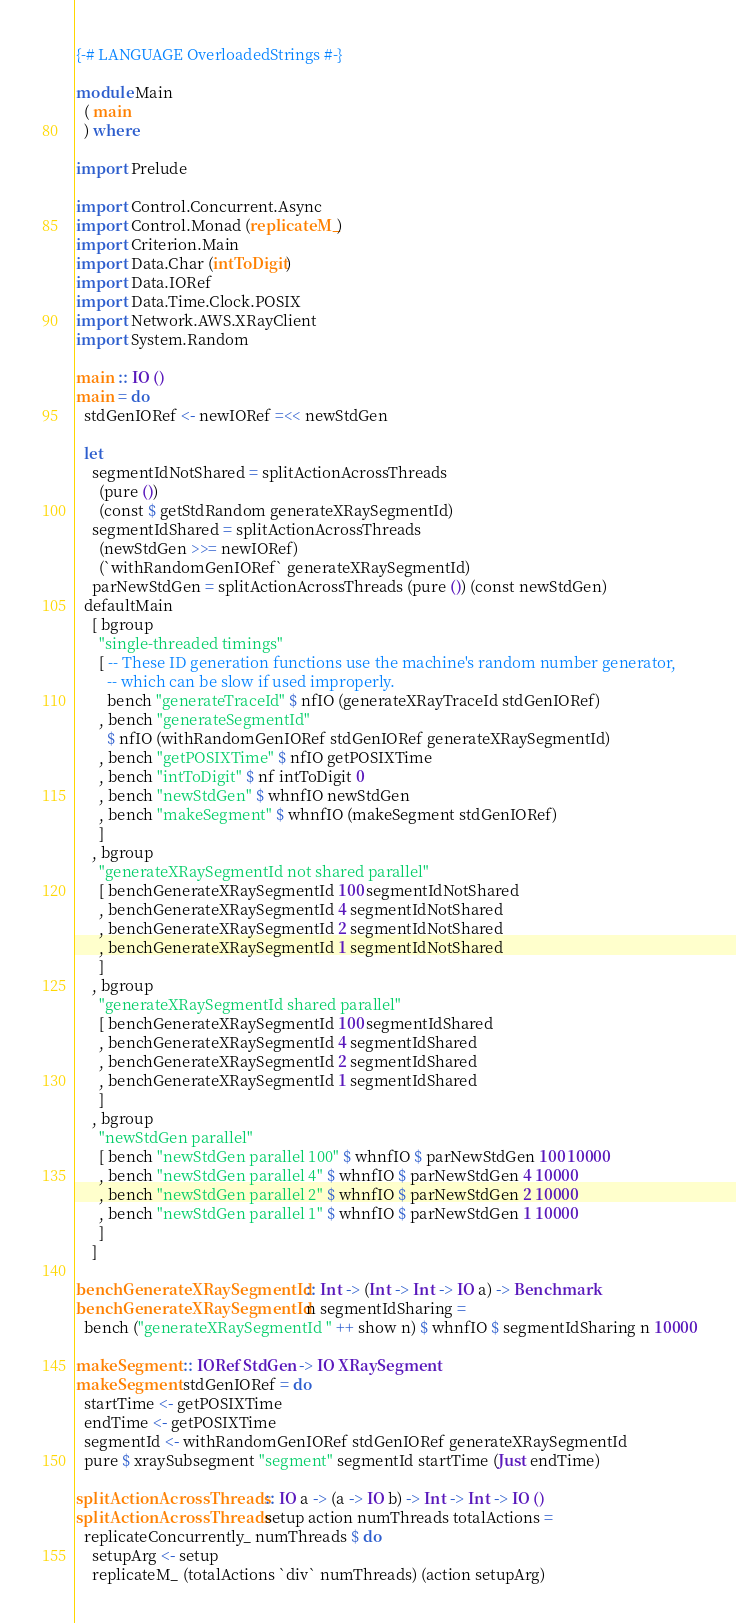Convert code to text. <code><loc_0><loc_0><loc_500><loc_500><_Haskell_>{-# LANGUAGE OverloadedStrings #-}

module Main
  ( main
  ) where

import Prelude

import Control.Concurrent.Async
import Control.Monad (replicateM_)
import Criterion.Main
import Data.Char (intToDigit)
import Data.IORef
import Data.Time.Clock.POSIX
import Network.AWS.XRayClient
import System.Random

main :: IO ()
main = do
  stdGenIORef <- newIORef =<< newStdGen

  let
    segmentIdNotShared = splitActionAcrossThreads
      (pure ())
      (const $ getStdRandom generateXRaySegmentId)
    segmentIdShared = splitActionAcrossThreads
      (newStdGen >>= newIORef)
      (`withRandomGenIORef` generateXRaySegmentId)
    parNewStdGen = splitActionAcrossThreads (pure ()) (const newStdGen)
  defaultMain
    [ bgroup
      "single-threaded timings"
      [ -- These ID generation functions use the machine's random number generator,
        -- which can be slow if used improperly.
        bench "generateTraceId" $ nfIO (generateXRayTraceId stdGenIORef)
      , bench "generateSegmentId"
        $ nfIO (withRandomGenIORef stdGenIORef generateXRaySegmentId)
      , bench "getPOSIXTime" $ nfIO getPOSIXTime
      , bench "intToDigit" $ nf intToDigit 0
      , bench "newStdGen" $ whnfIO newStdGen
      , bench "makeSegment" $ whnfIO (makeSegment stdGenIORef)
      ]
    , bgroup
      "generateXRaySegmentId not shared parallel"
      [ benchGenerateXRaySegmentId 100 segmentIdNotShared
      , benchGenerateXRaySegmentId 4 segmentIdNotShared
      , benchGenerateXRaySegmentId 2 segmentIdNotShared
      , benchGenerateXRaySegmentId 1 segmentIdNotShared
      ]
    , bgroup
      "generateXRaySegmentId shared parallel"
      [ benchGenerateXRaySegmentId 100 segmentIdShared
      , benchGenerateXRaySegmentId 4 segmentIdShared
      , benchGenerateXRaySegmentId 2 segmentIdShared
      , benchGenerateXRaySegmentId 1 segmentIdShared
      ]
    , bgroup
      "newStdGen parallel"
      [ bench "newStdGen parallel 100" $ whnfIO $ parNewStdGen 100 10000
      , bench "newStdGen parallel 4" $ whnfIO $ parNewStdGen 4 10000
      , bench "newStdGen parallel 2" $ whnfIO $ parNewStdGen 2 10000
      , bench "newStdGen parallel 1" $ whnfIO $ parNewStdGen 1 10000
      ]
    ]

benchGenerateXRaySegmentId :: Int -> (Int -> Int -> IO a) -> Benchmark
benchGenerateXRaySegmentId n segmentIdSharing =
  bench ("generateXRaySegmentId " ++ show n) $ whnfIO $ segmentIdSharing n 10000

makeSegment :: IORef StdGen -> IO XRaySegment
makeSegment stdGenIORef = do
  startTime <- getPOSIXTime
  endTime <- getPOSIXTime
  segmentId <- withRandomGenIORef stdGenIORef generateXRaySegmentId
  pure $ xraySubsegment "segment" segmentId startTime (Just endTime)

splitActionAcrossThreads :: IO a -> (a -> IO b) -> Int -> Int -> IO ()
splitActionAcrossThreads setup action numThreads totalActions =
  replicateConcurrently_ numThreads $ do
    setupArg <- setup
    replicateM_ (totalActions `div` numThreads) (action setupArg)
</code> 